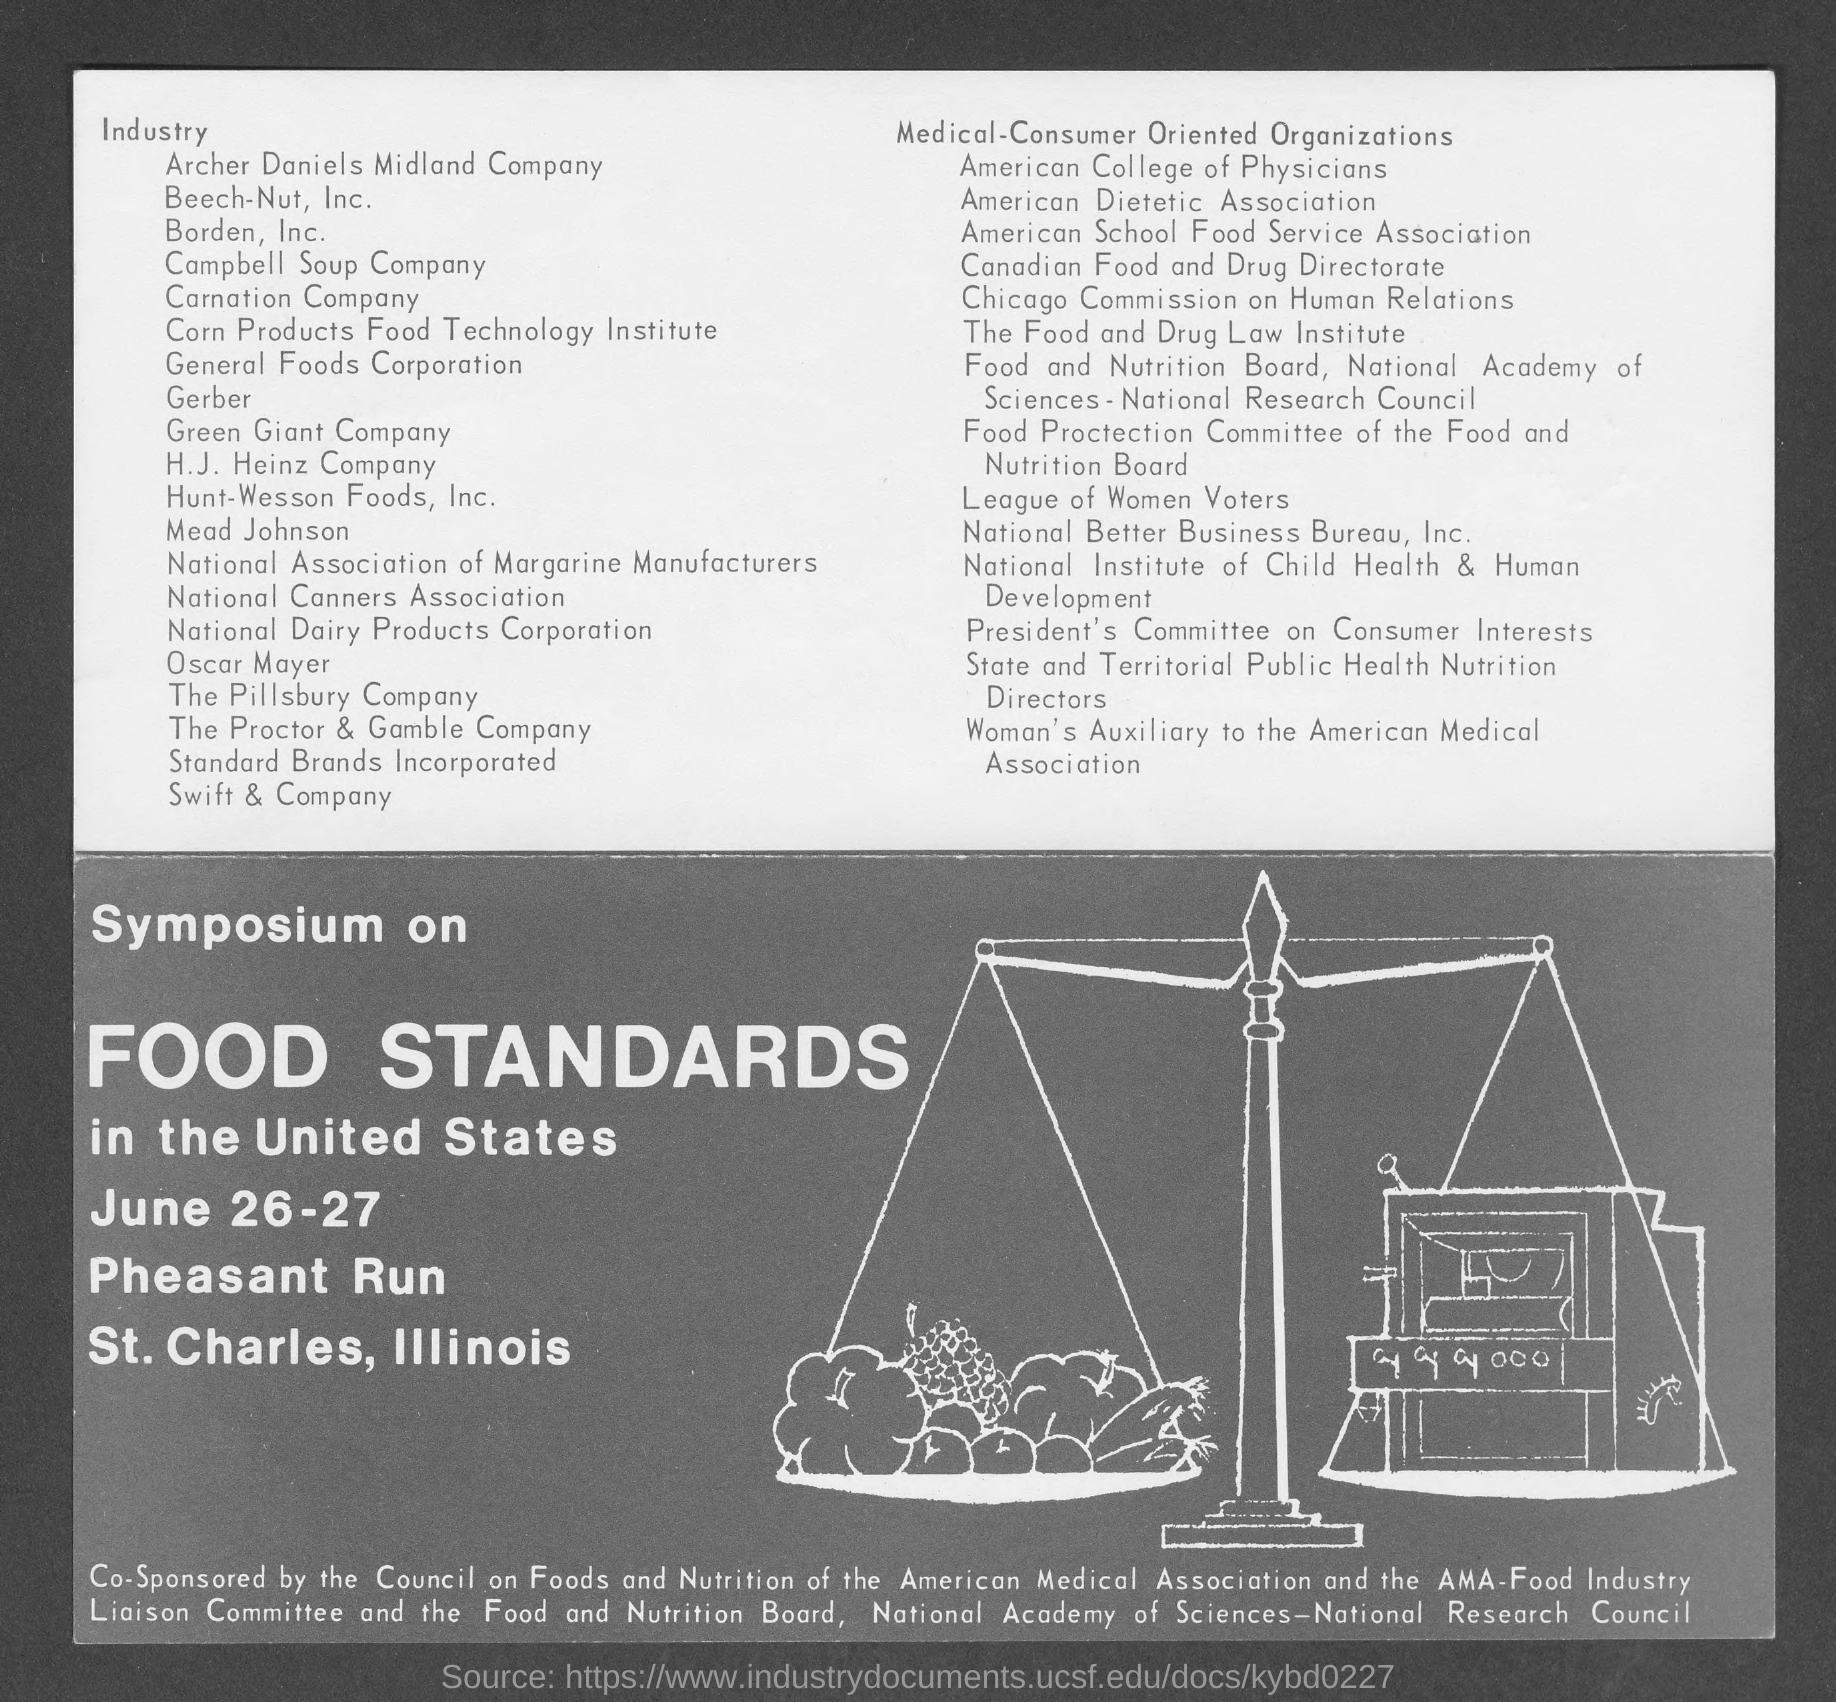When is the Symposium on Food Standards held?
Make the answer very short. June 26-27. 